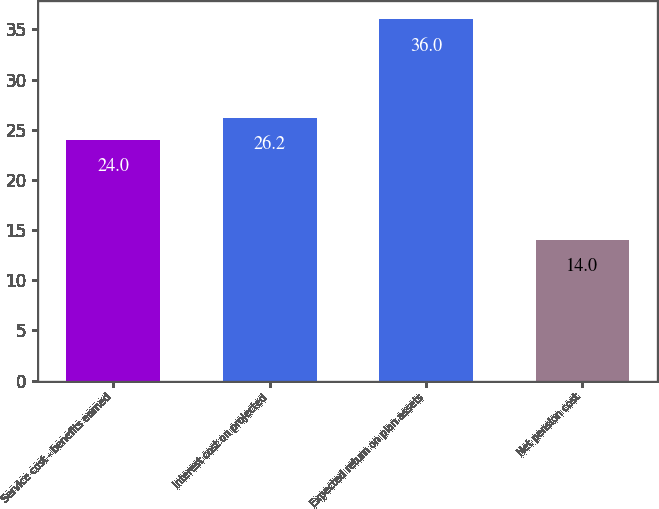<chart> <loc_0><loc_0><loc_500><loc_500><bar_chart><fcel>Service cost - benefits earned<fcel>Interest cost on projected<fcel>Expected return on plan assets<fcel>Net pension cost<nl><fcel>24<fcel>26.2<fcel>36<fcel>14<nl></chart> 